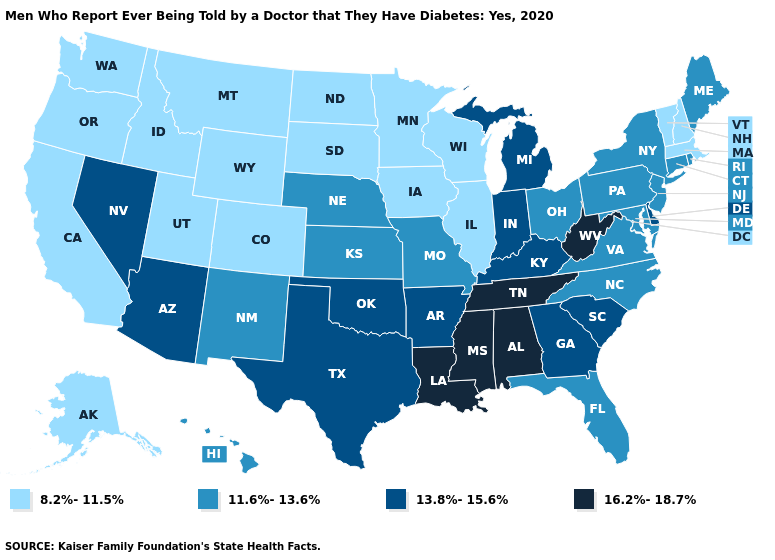What is the value of Oregon?
Quick response, please. 8.2%-11.5%. What is the lowest value in the Northeast?
Quick response, please. 8.2%-11.5%. What is the value of Pennsylvania?
Write a very short answer. 11.6%-13.6%. What is the value of Colorado?
Quick response, please. 8.2%-11.5%. Which states have the lowest value in the USA?
Short answer required. Alaska, California, Colorado, Idaho, Illinois, Iowa, Massachusetts, Minnesota, Montana, New Hampshire, North Dakota, Oregon, South Dakota, Utah, Vermont, Washington, Wisconsin, Wyoming. Does Maryland have the lowest value in the USA?
Concise answer only. No. Which states have the highest value in the USA?
Concise answer only. Alabama, Louisiana, Mississippi, Tennessee, West Virginia. What is the value of Oregon?
Give a very brief answer. 8.2%-11.5%. What is the highest value in the West ?
Give a very brief answer. 13.8%-15.6%. Name the states that have a value in the range 13.8%-15.6%?
Keep it brief. Arizona, Arkansas, Delaware, Georgia, Indiana, Kentucky, Michigan, Nevada, Oklahoma, South Carolina, Texas. What is the highest value in states that border Illinois?
Give a very brief answer. 13.8%-15.6%. Does Maryland have the same value as South Carolina?
Concise answer only. No. Does Pennsylvania have a higher value than Oregon?
Be succinct. Yes. 